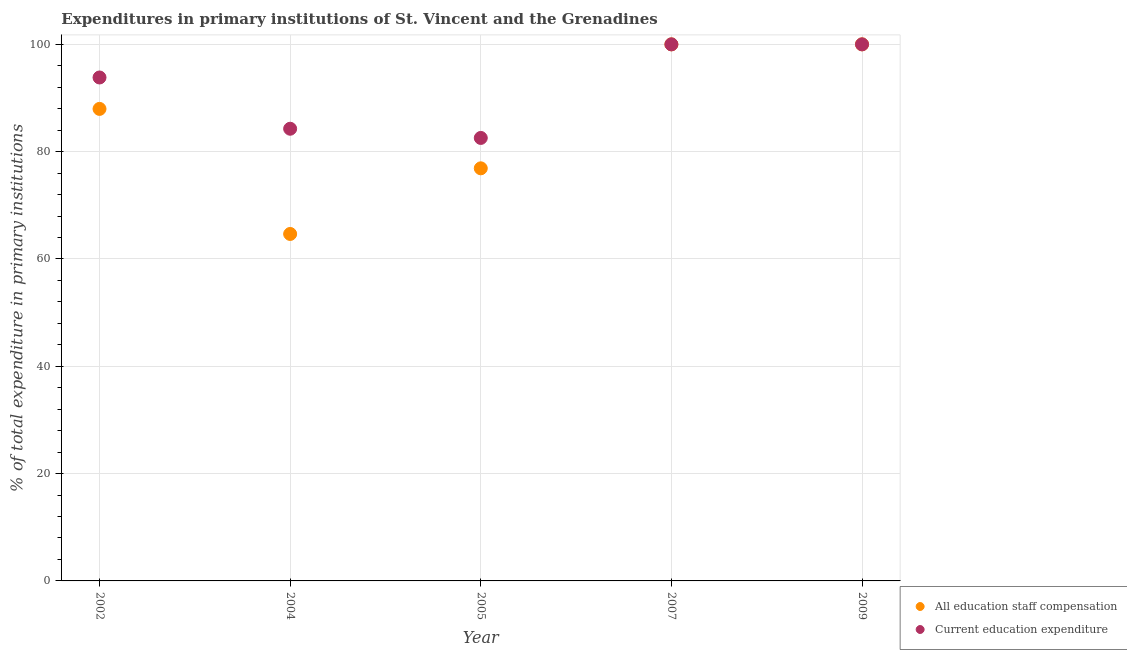How many different coloured dotlines are there?
Ensure brevity in your answer.  2. Is the number of dotlines equal to the number of legend labels?
Make the answer very short. Yes. What is the expenditure in staff compensation in 2002?
Offer a terse response. 87.97. Across all years, what is the minimum expenditure in education?
Your response must be concise. 82.56. In which year was the expenditure in staff compensation maximum?
Your answer should be very brief. 2007. In which year was the expenditure in staff compensation minimum?
Keep it short and to the point. 2004. What is the total expenditure in staff compensation in the graph?
Make the answer very short. 429.53. What is the difference between the expenditure in education in 2002 and the expenditure in staff compensation in 2004?
Provide a succinct answer. 29.16. What is the average expenditure in education per year?
Ensure brevity in your answer.  92.13. In the year 2007, what is the difference between the expenditure in education and expenditure in staff compensation?
Your answer should be very brief. 0. In how many years, is the expenditure in staff compensation greater than 24 %?
Provide a succinct answer. 5. What is the ratio of the expenditure in education in 2004 to that in 2007?
Make the answer very short. 0.84. Is the expenditure in staff compensation in 2004 less than that in 2007?
Your answer should be very brief. Yes. What is the difference between the highest and the second highest expenditure in education?
Ensure brevity in your answer.  0. What is the difference between the highest and the lowest expenditure in staff compensation?
Provide a succinct answer. 35.34. Is the sum of the expenditure in education in 2004 and 2007 greater than the maximum expenditure in staff compensation across all years?
Make the answer very short. Yes. Is the expenditure in education strictly greater than the expenditure in staff compensation over the years?
Offer a very short reply. No. How many dotlines are there?
Your response must be concise. 2. How many years are there in the graph?
Offer a very short reply. 5. What is the difference between two consecutive major ticks on the Y-axis?
Ensure brevity in your answer.  20. Are the values on the major ticks of Y-axis written in scientific E-notation?
Offer a terse response. No. Does the graph contain any zero values?
Make the answer very short. No. Does the graph contain grids?
Offer a very short reply. Yes. How are the legend labels stacked?
Provide a short and direct response. Vertical. What is the title of the graph?
Offer a very short reply. Expenditures in primary institutions of St. Vincent and the Grenadines. What is the label or title of the Y-axis?
Your answer should be compact. % of total expenditure in primary institutions. What is the % of total expenditure in primary institutions in All education staff compensation in 2002?
Offer a very short reply. 87.97. What is the % of total expenditure in primary institutions of Current education expenditure in 2002?
Provide a short and direct response. 93.83. What is the % of total expenditure in primary institutions of All education staff compensation in 2004?
Make the answer very short. 64.66. What is the % of total expenditure in primary institutions of Current education expenditure in 2004?
Your answer should be compact. 84.27. What is the % of total expenditure in primary institutions of All education staff compensation in 2005?
Ensure brevity in your answer.  76.9. What is the % of total expenditure in primary institutions in Current education expenditure in 2005?
Give a very brief answer. 82.56. Across all years, what is the maximum % of total expenditure in primary institutions of Current education expenditure?
Ensure brevity in your answer.  100. Across all years, what is the minimum % of total expenditure in primary institutions in All education staff compensation?
Your answer should be compact. 64.66. Across all years, what is the minimum % of total expenditure in primary institutions in Current education expenditure?
Your answer should be very brief. 82.56. What is the total % of total expenditure in primary institutions of All education staff compensation in the graph?
Your answer should be compact. 429.53. What is the total % of total expenditure in primary institutions in Current education expenditure in the graph?
Make the answer very short. 460.66. What is the difference between the % of total expenditure in primary institutions of All education staff compensation in 2002 and that in 2004?
Your response must be concise. 23.31. What is the difference between the % of total expenditure in primary institutions of Current education expenditure in 2002 and that in 2004?
Your answer should be compact. 9.55. What is the difference between the % of total expenditure in primary institutions in All education staff compensation in 2002 and that in 2005?
Make the answer very short. 11.07. What is the difference between the % of total expenditure in primary institutions of Current education expenditure in 2002 and that in 2005?
Your answer should be very brief. 11.27. What is the difference between the % of total expenditure in primary institutions of All education staff compensation in 2002 and that in 2007?
Offer a very short reply. -12.03. What is the difference between the % of total expenditure in primary institutions in Current education expenditure in 2002 and that in 2007?
Keep it short and to the point. -6.17. What is the difference between the % of total expenditure in primary institutions of All education staff compensation in 2002 and that in 2009?
Offer a very short reply. -12.03. What is the difference between the % of total expenditure in primary institutions in Current education expenditure in 2002 and that in 2009?
Keep it short and to the point. -6.17. What is the difference between the % of total expenditure in primary institutions in All education staff compensation in 2004 and that in 2005?
Offer a very short reply. -12.23. What is the difference between the % of total expenditure in primary institutions in Current education expenditure in 2004 and that in 2005?
Give a very brief answer. 1.71. What is the difference between the % of total expenditure in primary institutions in All education staff compensation in 2004 and that in 2007?
Your answer should be very brief. -35.34. What is the difference between the % of total expenditure in primary institutions of Current education expenditure in 2004 and that in 2007?
Give a very brief answer. -15.73. What is the difference between the % of total expenditure in primary institutions in All education staff compensation in 2004 and that in 2009?
Ensure brevity in your answer.  -35.34. What is the difference between the % of total expenditure in primary institutions in Current education expenditure in 2004 and that in 2009?
Offer a terse response. -15.73. What is the difference between the % of total expenditure in primary institutions in All education staff compensation in 2005 and that in 2007?
Keep it short and to the point. -23.1. What is the difference between the % of total expenditure in primary institutions in Current education expenditure in 2005 and that in 2007?
Keep it short and to the point. -17.44. What is the difference between the % of total expenditure in primary institutions in All education staff compensation in 2005 and that in 2009?
Provide a succinct answer. -23.1. What is the difference between the % of total expenditure in primary institutions in Current education expenditure in 2005 and that in 2009?
Your response must be concise. -17.44. What is the difference between the % of total expenditure in primary institutions in Current education expenditure in 2007 and that in 2009?
Keep it short and to the point. 0. What is the difference between the % of total expenditure in primary institutions of All education staff compensation in 2002 and the % of total expenditure in primary institutions of Current education expenditure in 2004?
Offer a terse response. 3.7. What is the difference between the % of total expenditure in primary institutions in All education staff compensation in 2002 and the % of total expenditure in primary institutions in Current education expenditure in 2005?
Make the answer very short. 5.41. What is the difference between the % of total expenditure in primary institutions of All education staff compensation in 2002 and the % of total expenditure in primary institutions of Current education expenditure in 2007?
Your answer should be compact. -12.03. What is the difference between the % of total expenditure in primary institutions of All education staff compensation in 2002 and the % of total expenditure in primary institutions of Current education expenditure in 2009?
Your answer should be very brief. -12.03. What is the difference between the % of total expenditure in primary institutions in All education staff compensation in 2004 and the % of total expenditure in primary institutions in Current education expenditure in 2005?
Provide a succinct answer. -17.9. What is the difference between the % of total expenditure in primary institutions of All education staff compensation in 2004 and the % of total expenditure in primary institutions of Current education expenditure in 2007?
Your answer should be very brief. -35.34. What is the difference between the % of total expenditure in primary institutions of All education staff compensation in 2004 and the % of total expenditure in primary institutions of Current education expenditure in 2009?
Keep it short and to the point. -35.34. What is the difference between the % of total expenditure in primary institutions in All education staff compensation in 2005 and the % of total expenditure in primary institutions in Current education expenditure in 2007?
Offer a terse response. -23.1. What is the difference between the % of total expenditure in primary institutions of All education staff compensation in 2005 and the % of total expenditure in primary institutions of Current education expenditure in 2009?
Offer a terse response. -23.1. What is the average % of total expenditure in primary institutions in All education staff compensation per year?
Make the answer very short. 85.91. What is the average % of total expenditure in primary institutions in Current education expenditure per year?
Offer a very short reply. 92.13. In the year 2002, what is the difference between the % of total expenditure in primary institutions in All education staff compensation and % of total expenditure in primary institutions in Current education expenditure?
Provide a short and direct response. -5.86. In the year 2004, what is the difference between the % of total expenditure in primary institutions of All education staff compensation and % of total expenditure in primary institutions of Current education expenditure?
Your answer should be very brief. -19.61. In the year 2005, what is the difference between the % of total expenditure in primary institutions of All education staff compensation and % of total expenditure in primary institutions of Current education expenditure?
Your answer should be very brief. -5.66. In the year 2009, what is the difference between the % of total expenditure in primary institutions of All education staff compensation and % of total expenditure in primary institutions of Current education expenditure?
Provide a short and direct response. 0. What is the ratio of the % of total expenditure in primary institutions in All education staff compensation in 2002 to that in 2004?
Provide a succinct answer. 1.36. What is the ratio of the % of total expenditure in primary institutions in Current education expenditure in 2002 to that in 2004?
Provide a succinct answer. 1.11. What is the ratio of the % of total expenditure in primary institutions in All education staff compensation in 2002 to that in 2005?
Keep it short and to the point. 1.14. What is the ratio of the % of total expenditure in primary institutions in Current education expenditure in 2002 to that in 2005?
Give a very brief answer. 1.14. What is the ratio of the % of total expenditure in primary institutions of All education staff compensation in 2002 to that in 2007?
Keep it short and to the point. 0.88. What is the ratio of the % of total expenditure in primary institutions in Current education expenditure in 2002 to that in 2007?
Provide a short and direct response. 0.94. What is the ratio of the % of total expenditure in primary institutions of All education staff compensation in 2002 to that in 2009?
Make the answer very short. 0.88. What is the ratio of the % of total expenditure in primary institutions of Current education expenditure in 2002 to that in 2009?
Offer a very short reply. 0.94. What is the ratio of the % of total expenditure in primary institutions of All education staff compensation in 2004 to that in 2005?
Provide a succinct answer. 0.84. What is the ratio of the % of total expenditure in primary institutions in Current education expenditure in 2004 to that in 2005?
Make the answer very short. 1.02. What is the ratio of the % of total expenditure in primary institutions in All education staff compensation in 2004 to that in 2007?
Your answer should be compact. 0.65. What is the ratio of the % of total expenditure in primary institutions in Current education expenditure in 2004 to that in 2007?
Provide a short and direct response. 0.84. What is the ratio of the % of total expenditure in primary institutions in All education staff compensation in 2004 to that in 2009?
Your answer should be very brief. 0.65. What is the ratio of the % of total expenditure in primary institutions of Current education expenditure in 2004 to that in 2009?
Ensure brevity in your answer.  0.84. What is the ratio of the % of total expenditure in primary institutions of All education staff compensation in 2005 to that in 2007?
Ensure brevity in your answer.  0.77. What is the ratio of the % of total expenditure in primary institutions in Current education expenditure in 2005 to that in 2007?
Offer a very short reply. 0.83. What is the ratio of the % of total expenditure in primary institutions of All education staff compensation in 2005 to that in 2009?
Your answer should be compact. 0.77. What is the ratio of the % of total expenditure in primary institutions of Current education expenditure in 2005 to that in 2009?
Give a very brief answer. 0.83. What is the ratio of the % of total expenditure in primary institutions in All education staff compensation in 2007 to that in 2009?
Offer a very short reply. 1. What is the ratio of the % of total expenditure in primary institutions in Current education expenditure in 2007 to that in 2009?
Provide a short and direct response. 1. What is the difference between the highest and the lowest % of total expenditure in primary institutions of All education staff compensation?
Your response must be concise. 35.34. What is the difference between the highest and the lowest % of total expenditure in primary institutions of Current education expenditure?
Your response must be concise. 17.44. 